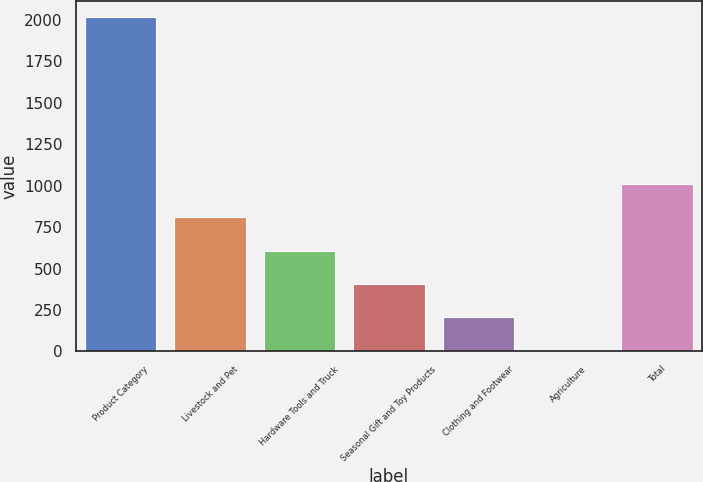Convert chart to OTSL. <chart><loc_0><loc_0><loc_500><loc_500><bar_chart><fcel>Product Category<fcel>Livestock and Pet<fcel>Hardware Tools and Truck<fcel>Seasonal Gift and Toy Products<fcel>Clothing and Footwear<fcel>Agriculture<fcel>Total<nl><fcel>2015<fcel>809<fcel>608<fcel>407<fcel>206<fcel>5<fcel>1010<nl></chart> 